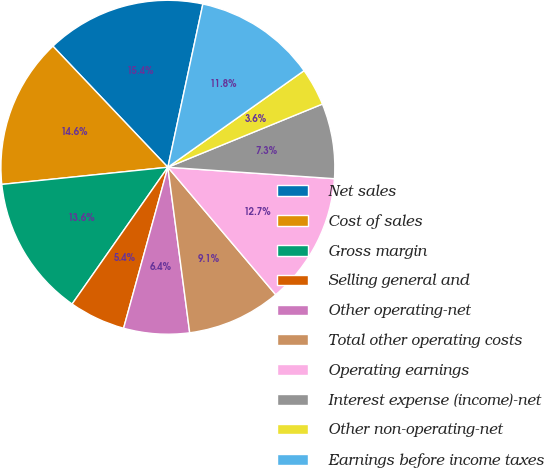<chart> <loc_0><loc_0><loc_500><loc_500><pie_chart><fcel>Net sales<fcel>Cost of sales<fcel>Gross margin<fcel>Selling general and<fcel>Other operating-net<fcel>Total other operating costs<fcel>Operating earnings<fcel>Interest expense (income)-net<fcel>Other non-operating-net<fcel>Earnings before income taxes<nl><fcel>15.45%<fcel>14.55%<fcel>13.64%<fcel>5.45%<fcel>6.36%<fcel>9.09%<fcel>12.73%<fcel>7.27%<fcel>3.64%<fcel>11.82%<nl></chart> 